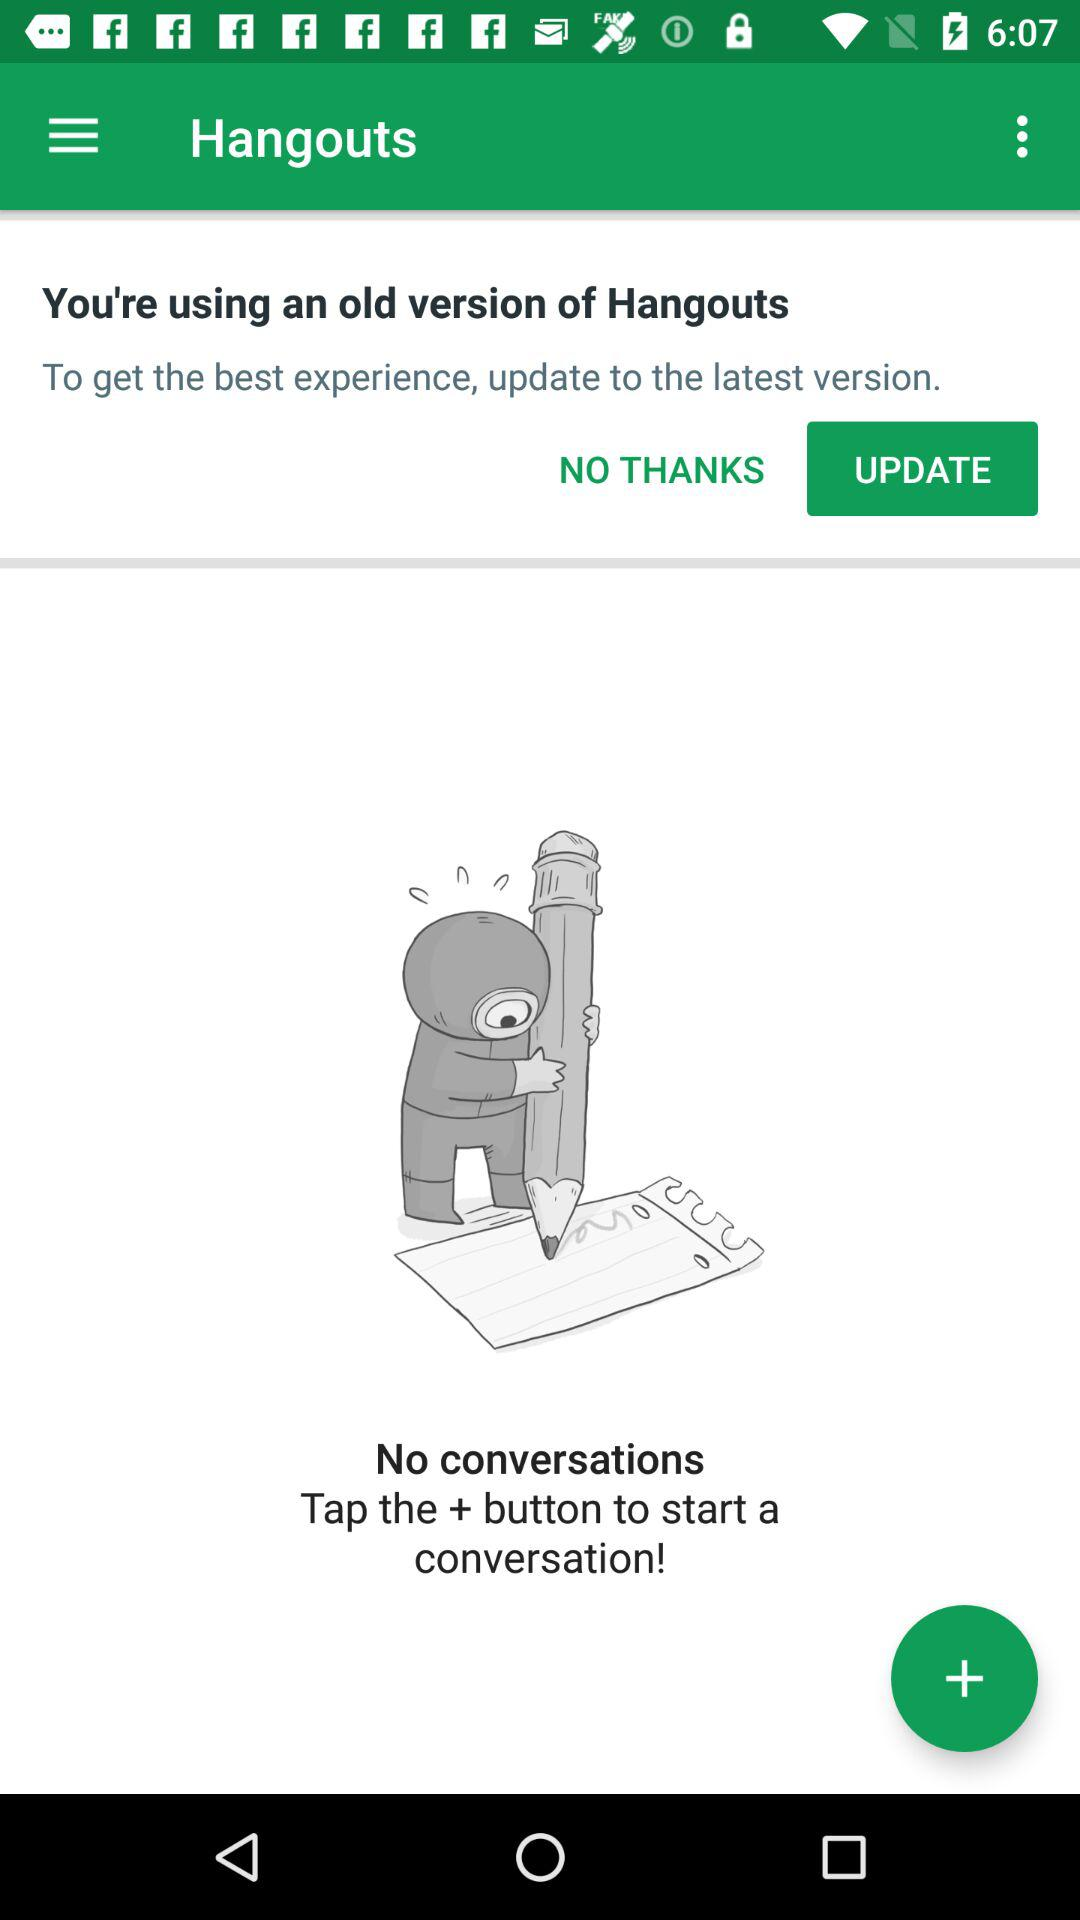Which option is highlighted for updating the latest version? The option is "UPDATE". 